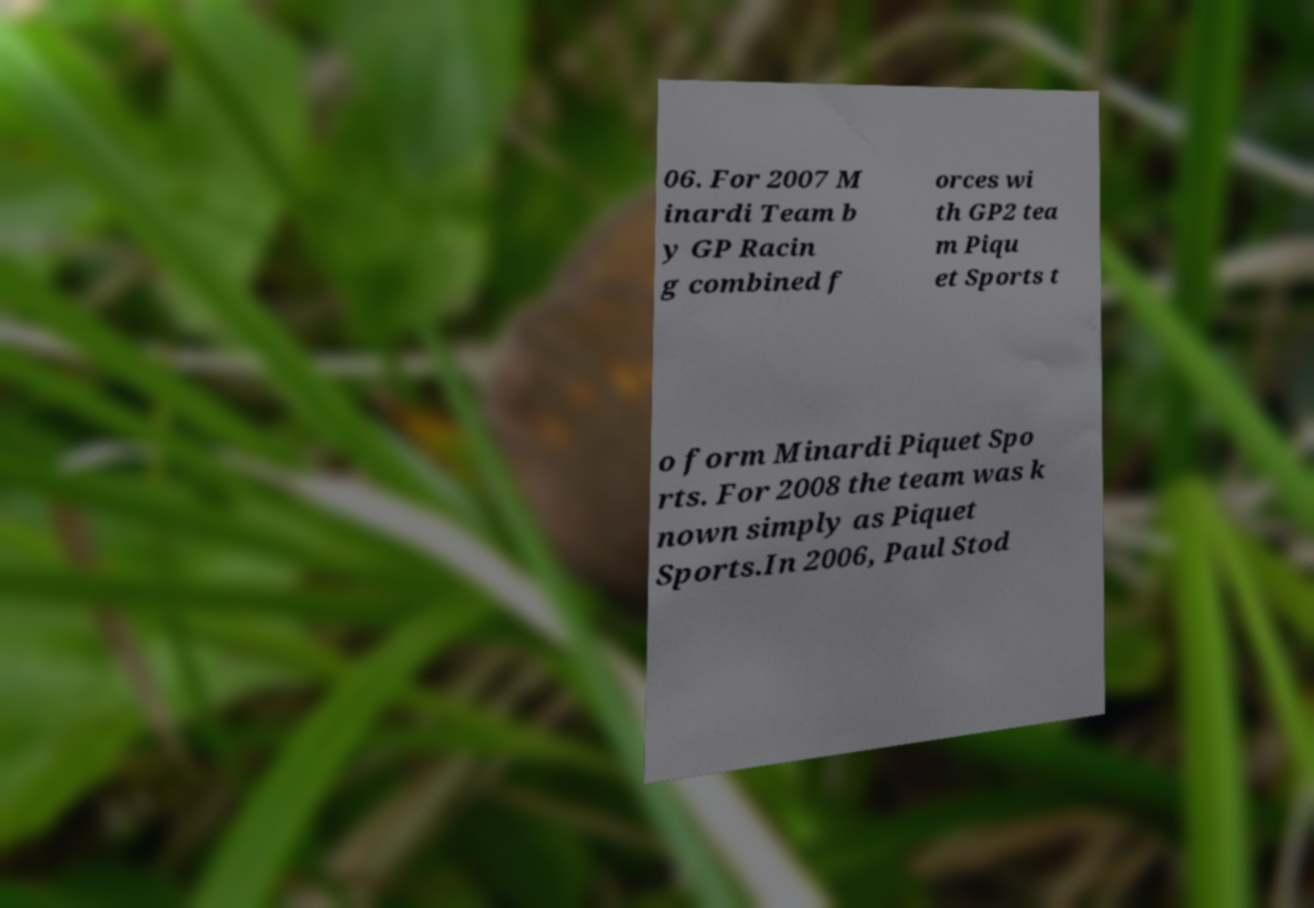There's text embedded in this image that I need extracted. Can you transcribe it verbatim? 06. For 2007 M inardi Team b y GP Racin g combined f orces wi th GP2 tea m Piqu et Sports t o form Minardi Piquet Spo rts. For 2008 the team was k nown simply as Piquet Sports.In 2006, Paul Stod 